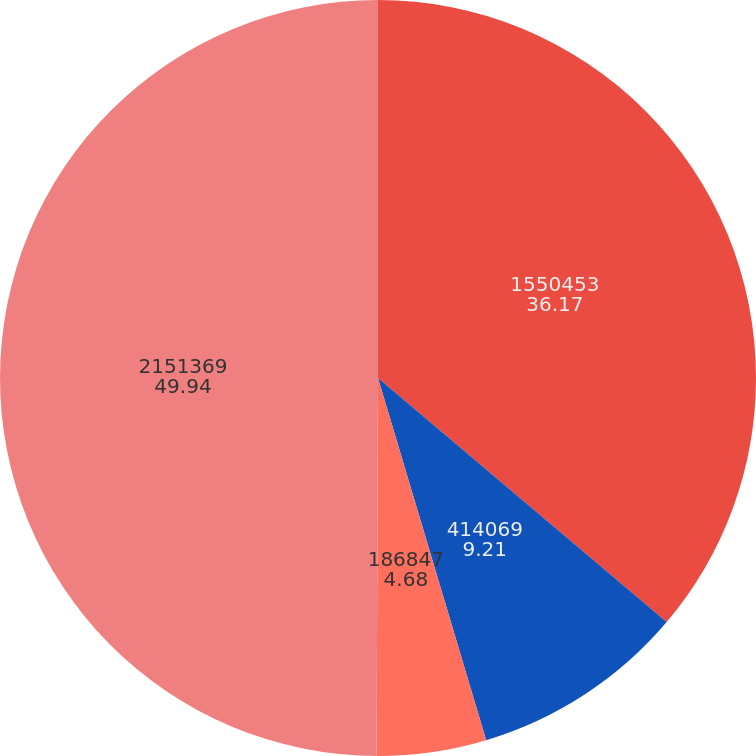Convert chart. <chart><loc_0><loc_0><loc_500><loc_500><pie_chart><fcel>1550453<fcel>414069<fcel>186847<fcel>2151369<nl><fcel>36.17%<fcel>9.21%<fcel>4.68%<fcel>49.94%<nl></chart> 